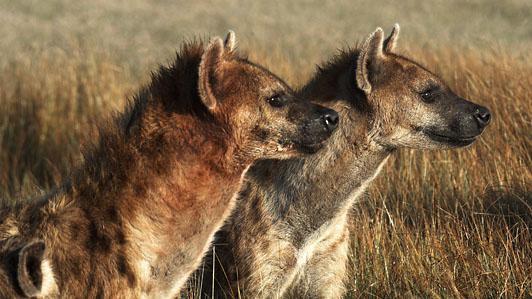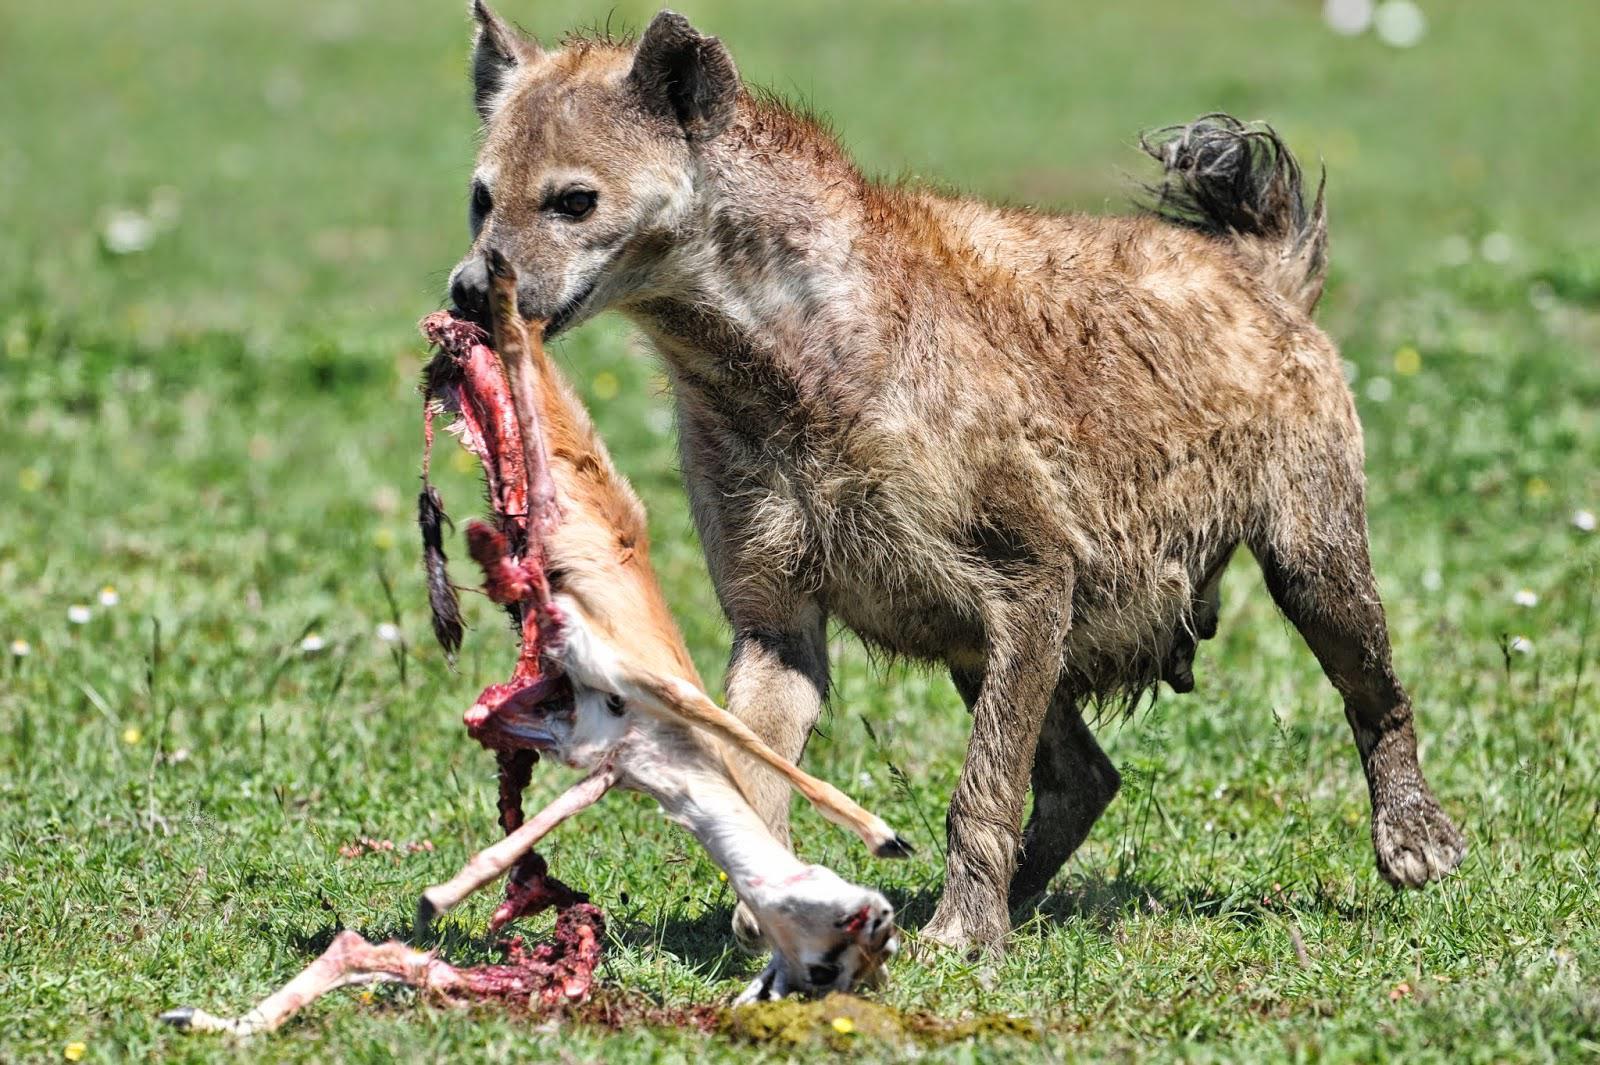The first image is the image on the left, the second image is the image on the right. Examine the images to the left and right. Is the description "An image shows an open-mouthed lion next to at least one hyena." accurate? Answer yes or no. No. The first image is the image on the left, the second image is the image on the right. For the images shown, is this caption "There are two hyenas in one of the images, and a lion near one or more hyenas in the other." true? Answer yes or no. No. 